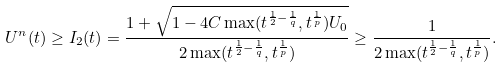<formula> <loc_0><loc_0><loc_500><loc_500>U ^ { n } ( t ) \geq I _ { 2 } ( t ) = \frac { 1 + \sqrt { 1 - 4 C \max ( t ^ { \frac { 1 } { 2 } - \frac { 1 } { q } } , t ^ { \frac { 1 } { p } } ) U _ { 0 } } } { 2 \max ( t ^ { \frac { 1 } { 2 } - \frac { 1 } { q } } , t ^ { \frac { 1 } { p } } ) } \geq \frac { 1 } { 2 \max ( t ^ { \frac { 1 } { 2 } - \frac { 1 } { q } } , t ^ { \frac { 1 } { p } } ) } .</formula> 